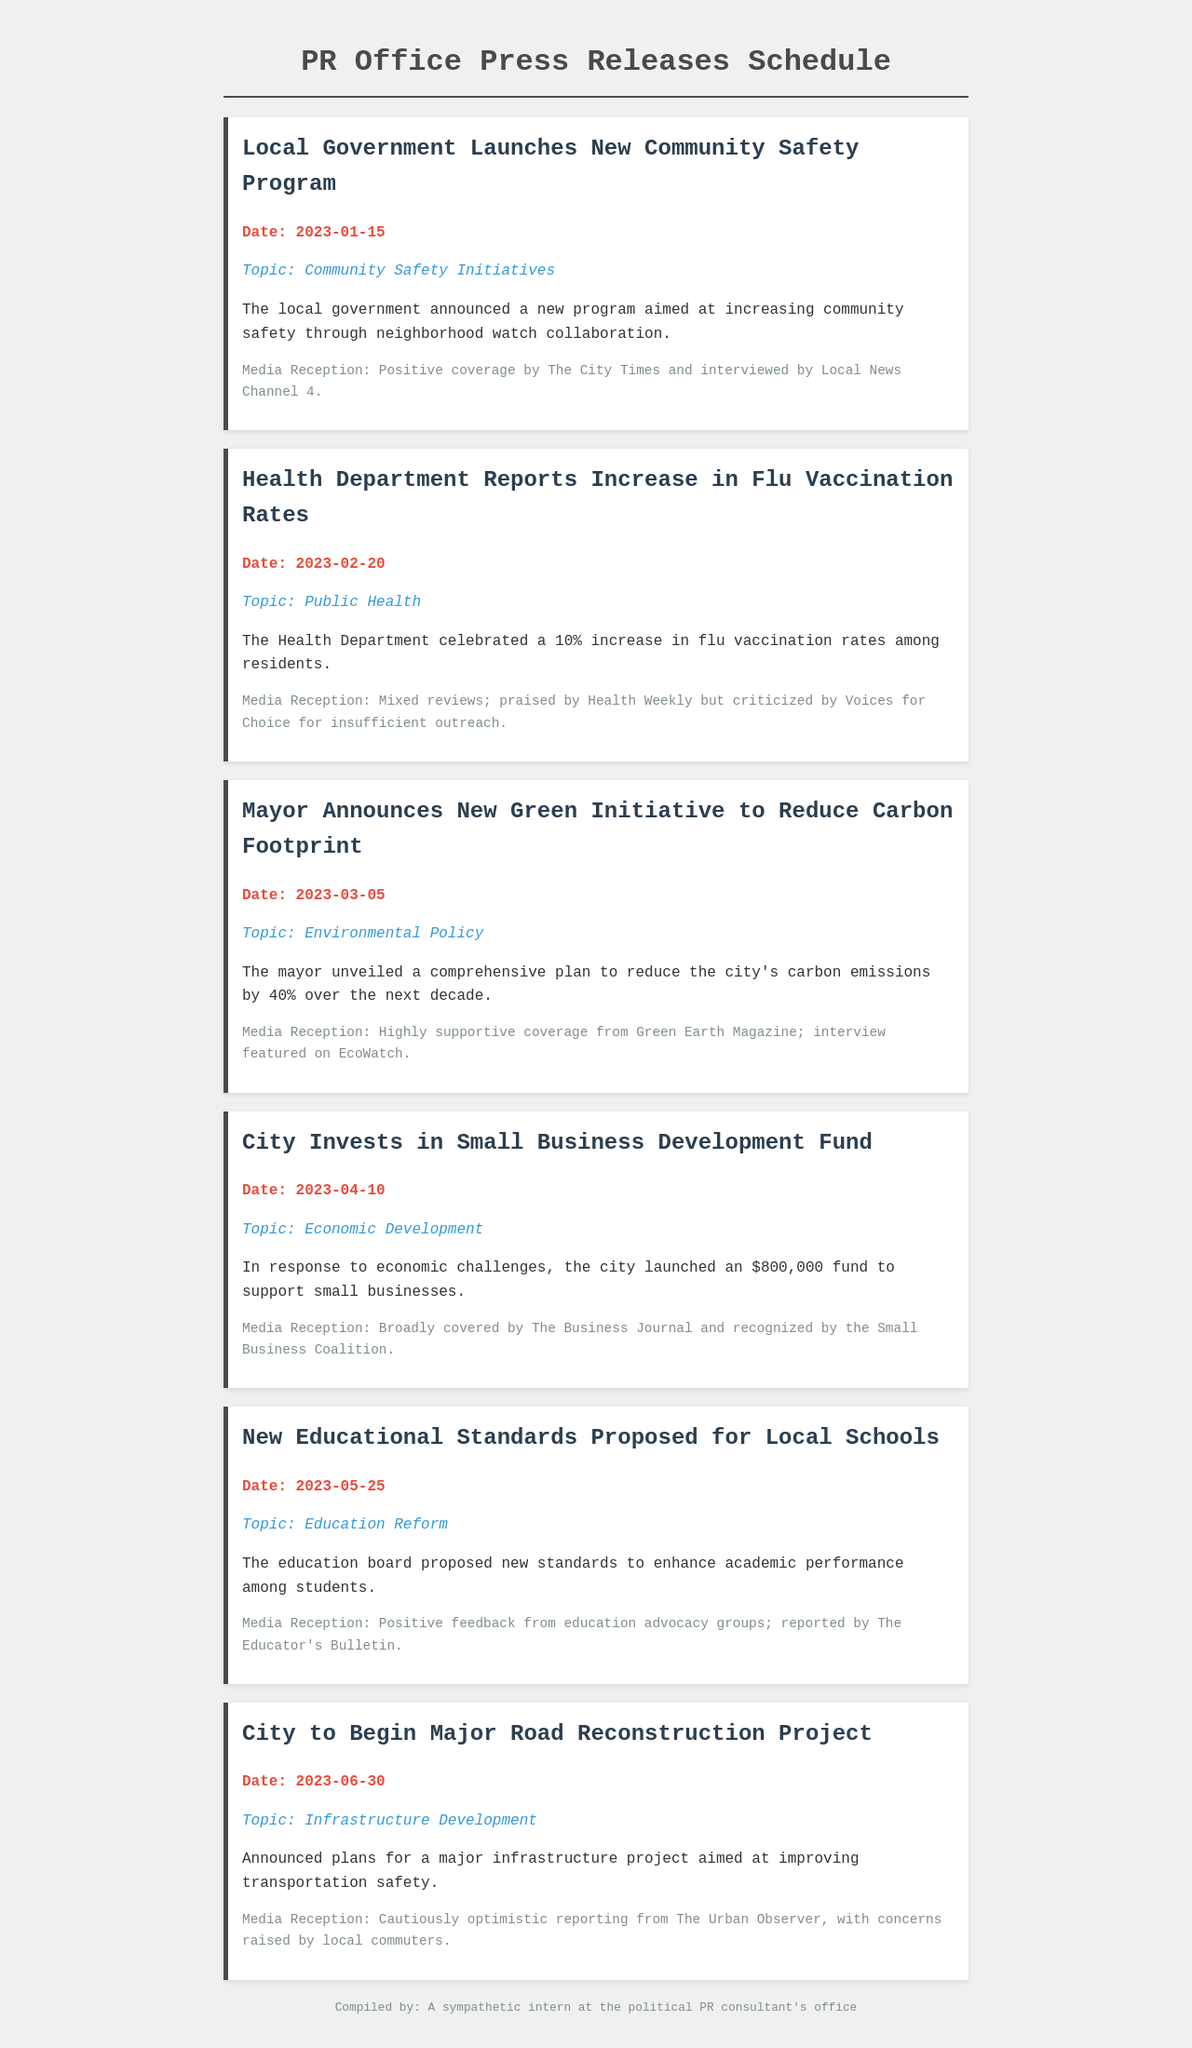What is the date of the press release about the Green Initiative? The date is specified in the press release for the Green Initiative, which is March 5, 2023.
Answer: March 5, 2023 What topic does the press release on January 15 discuss? The topic mentioned in the press release dated January 15 is Community Safety Initiatives.
Answer: Community Safety Initiatives How much funding was announced for small business development? The amount of funding announced for small business development is specified as $800,000 in the corresponding press release.
Answer: $800,000 Which media outlet provided positive coverage for the Community Safety Program? The City Times is highlighted as a media outlet that provided positive coverage for the Community Safety Program in the document.
Answer: The City Times What was the summary of the press release on April 10? The summary for the press release on April 10 discusses launching a fund to support small businesses in response to economic challenges.
Answer: City launched an $800,000 fund to support small businesses What was the media reception for the press release about the new educational standards? The media reception for the press release about the new educational standards included positive feedback from education advocacy groups.
Answer: Positive feedback from education advocacy groups Which press release received mixed reviews? The press release that received mixed reviews is about the increase in flu vaccination rates as stated in the document.
Answer: Health Department Reports Increase in Flu Vaccination Rates What is the topic of the press release issued on February 20? The topic for the press release issued on February 20 is Public Health, which addresses vaccination rates.
Answer: Public Health 